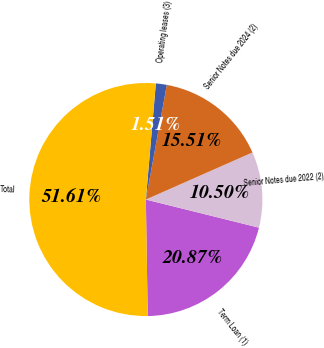Convert chart. <chart><loc_0><loc_0><loc_500><loc_500><pie_chart><fcel>Term Loan (1)<fcel>Senior Notes due 2022 (2)<fcel>Senior Notes due 2024 (2)<fcel>Operating leases (3)<fcel>Total<nl><fcel>20.87%<fcel>10.5%<fcel>15.51%<fcel>1.51%<fcel>51.62%<nl></chart> 